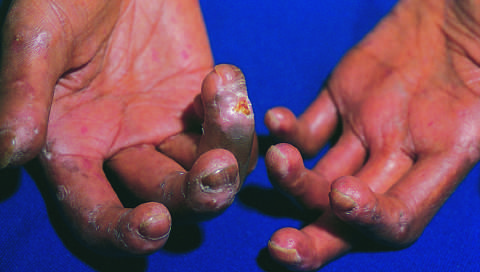what has led to cutaneous ulcerations?
Answer the question using a single word or phrase. Loss of blood supply 